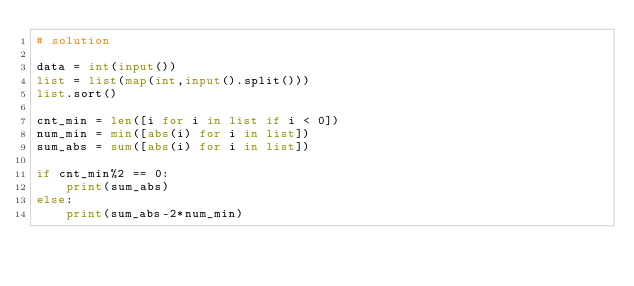<code> <loc_0><loc_0><loc_500><loc_500><_Python_># solution

data = int(input())
list = list(map(int,input().split()))
list.sort()

cnt_min = len([i for i in list if i < 0])
num_min = min([abs(i) for i in list])
sum_abs = sum([abs(i) for i in list])

if cnt_min%2 == 0:
    print(sum_abs)
else:
    print(sum_abs-2*num_min)</code> 